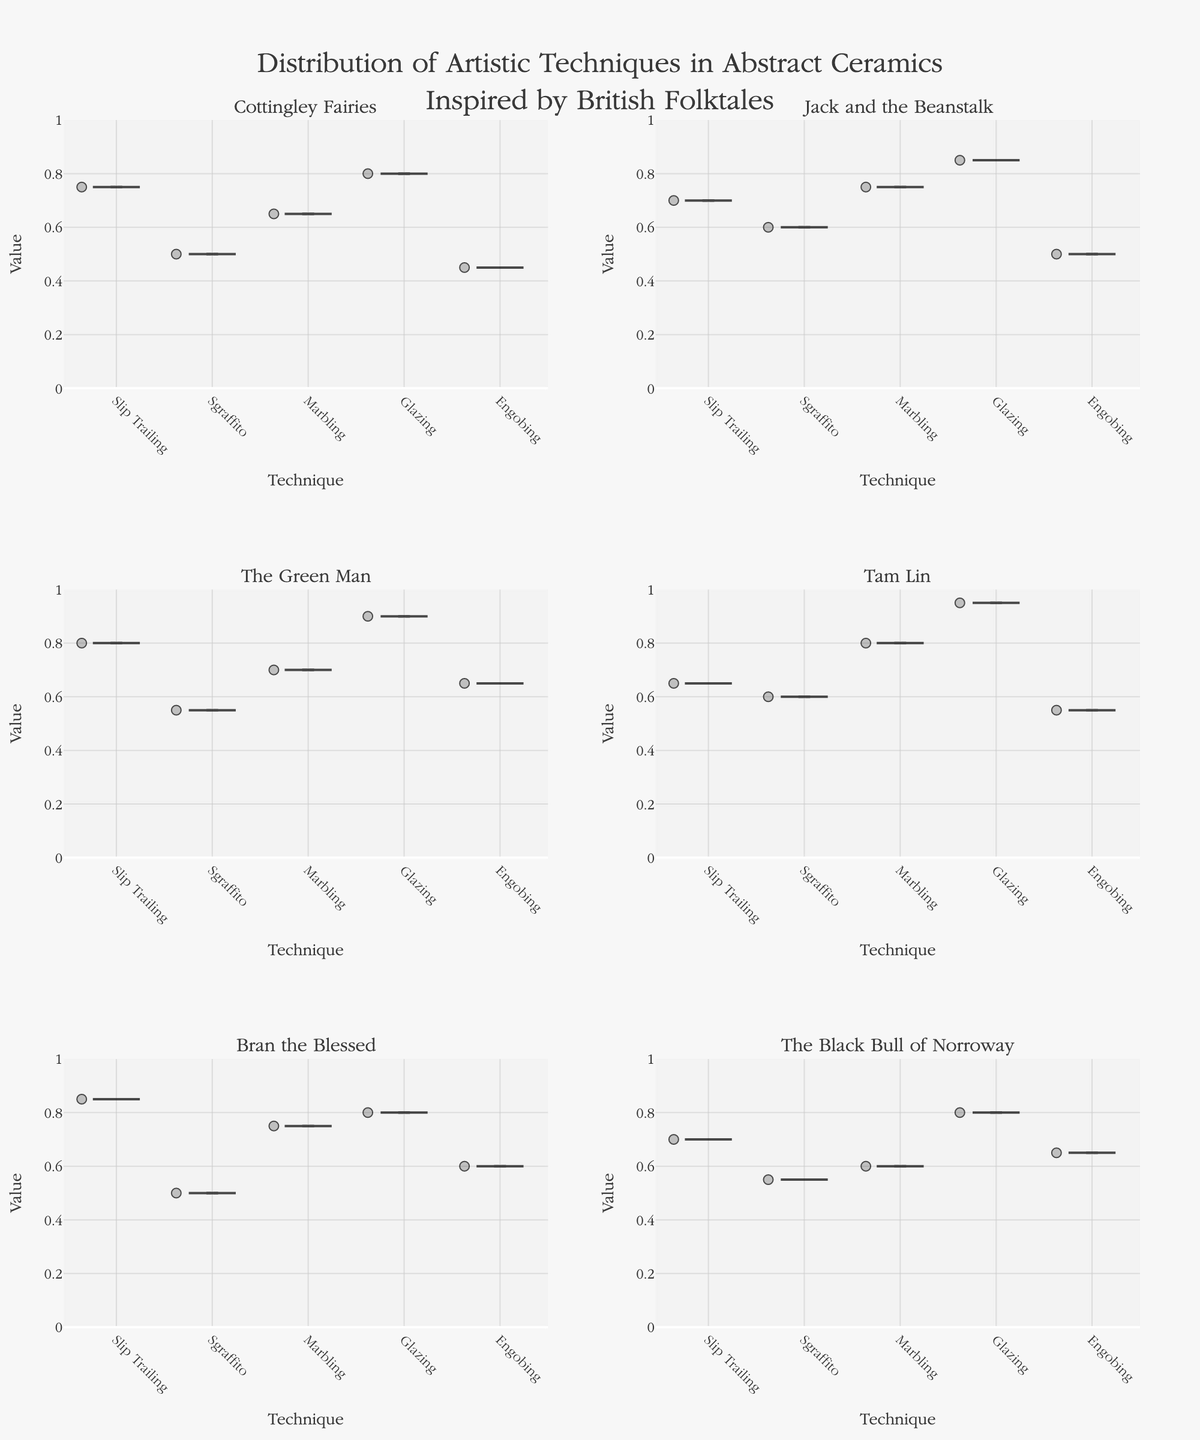What's the title of the figure? The title is centrally located at the top of the figure and provides an overall description of what the figure represents. It reads "Distribution of Artistic Techniques in Abstract Ceramics Inspired by British Folktales".
Answer: Distribution of Artistic Techniques in Abstract Ceramics Inspired by British Folktales In the "Tam Lin" subplot, which technique has the highest median value? Within each violin plot, there is a horizontal line that represents the median value. For the "Tam Lin" subplot, the technique with the highest median value is Glazing.
Answer: Glazing How does the value range for Glazing in "The Green Man" compare to that in "Tam Lin"? The value range of a technique can be assessed by observing how far it extends vertically in the violin plot. For "The Green Man", Glazing ranges roughly from 0.70 to 0.90, while in "Tam Lin" it ranges approximately from 0.80 to 0.95.
Answer: The range in "Tam Lin" is higher Which folktale has the lowest median value for Engobing? You can determine this by looking at the horizontal median line within the Engobing violin plot for each folktale. The lowest median value for Engobing is found in "Cottingley Fairies".
Answer: Cottingley Fairies Which technique shows the highest variation in values within the "Bran the Blessed" subplot? Variation within a violin plot can be observed by the spread or width of the plot. In "Bran the Blessed", the technique with the widest spread, indicating the highest variation, is Slip Trailing.
Answer: Slip Trailing Compare the use of Marbling in "Jack and the Beanstalk" and "The Black Bull of Norroway". Which has a higher median value? By observing the horizontal median lines in the Marbling violin plots for both "Jack and the Beanstalk" and "The Black Bull of Norroway", it is evident that "Jack and the Beanstalk" has a higher median value.
Answer: Jack and the Beanstalk What can you infer about the consistency of Slip Trailing values across all folktales? Consistency can be inferred from the spread and density of the violin plots. Slip Trailing values across all folktales show varied spreads, indicating inconsistency in their application. Some folktales like "Bran the Blessed" show a wide spread, while others like "Cottingley Fairies" have a narrower spread.
Answer: Inconsistent Among the techniques shown in "The Green Man", which has the narrowest range of values? The narrowest range of values can be seen by observing the vertical spread of the violin plot. In "The Green Man", Sgraffito has the narrowest vertical spread, indicating a smaller range of values.
Answer: Sgraffito If you were to select a technique with a generally higher value across the folktales, which one would it be? Looking at the median lines and general distribution across all subplots, Glazing often appears at or near the top in each subplot. This suggests that Glazing generally has higher values across the folktales.
Answer: Glazing Which folktale has the greatest range of values for Sgraffito? The range of values can be observed by the vertical span of the violin plot. For Sgraffito, the subplot "Jack and the Beanstalk" seems to have the greatest range, as it spans from around 0.30 to 0.60.
Answer: Jack and the Beanstalk 